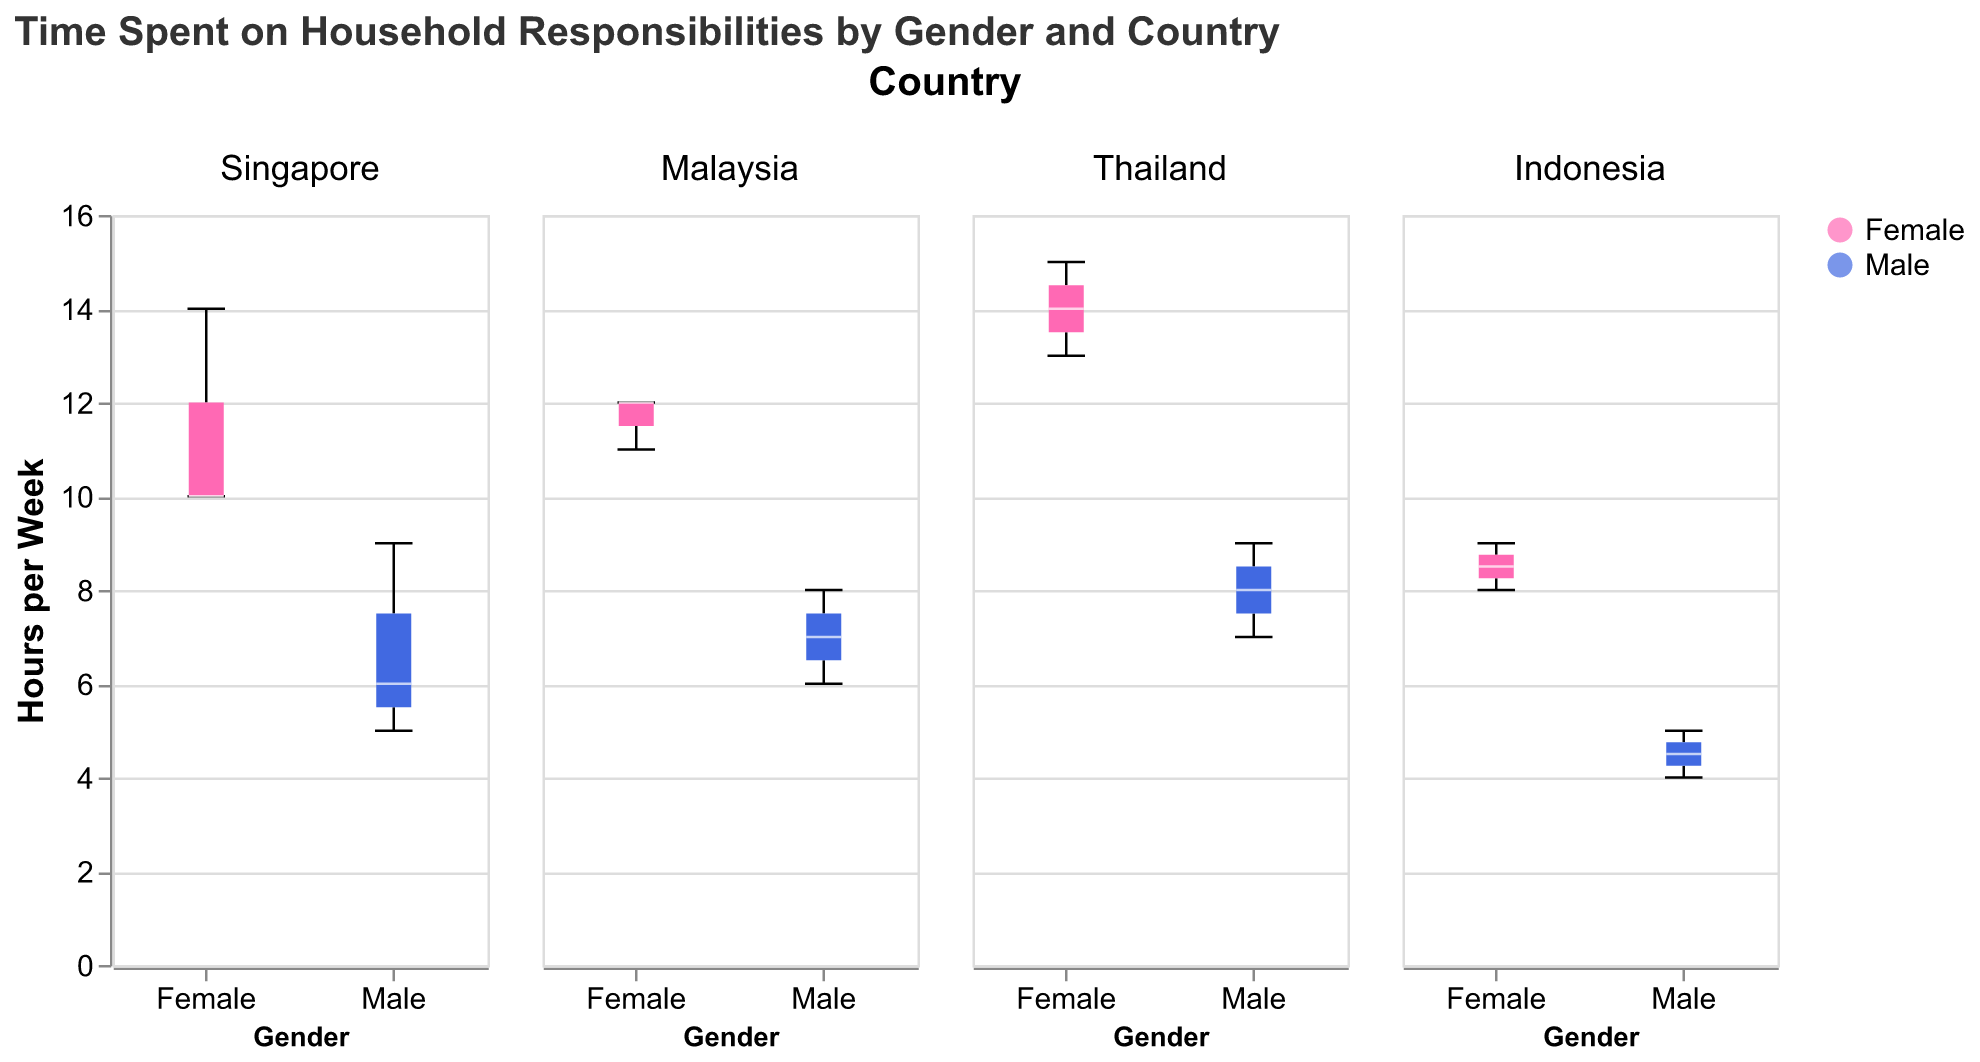What is the title of the plot? The title is located at the top of the figure. It is written in larger font size, making it easily identifiable.
Answer: Time Spent on Household Responsibilities by Gender and Country Which country has the highest median hours spent on household responsibilities for females? To find the country with the highest median, compare the central lines (which represent the medians) of the female box plots across the different countries.
Answer: Thailand What is the median number of hours spent on household responsibilities by males in Singapore? The median is represented by the central line inside the box plot. Locate the box plot for Singapore and the 'Male' category.
Answer: 7 hours How do the median hours spent on household responsibilities compare between males and females in Malaysia? Identify the median lines in the Malaysia subgroup for both genders. Compare their heights to determine which is higher. The female plot has a higher median.
Answer: Females have higher median hours than males What is the interquartile range (IQR) for females in Thailand? The IQR is the difference between the third quartile (top edge of the box) and the first quartile (bottom edge of the box). Measure this visually for the female box plot in Thailand.
Answer: Approximately 3 to 5 hours Which gender has a wider distribution of data points for household responsibilities in Indonesia? The width of the distribution can be observed by the length of the box plot and the whiskers. Compare these lengths between males and females in Indonesia.
Answer: Females Which gender has a more consistent (less varied) range of household responsibility hours in Singapore? A more consistent range is indicated by a shorter box plot. Compare the lengths of the box plots for both genders in Singapore.
Answer: Males In which country is the difference in median household responsibilities between genders the smallest? Compare the median lines for males and females across all countries and find the country where these lines are closest.
Answer: Indonesia What's the maximum number of hours spent on household responsibilities by females in Malaysia? The maximum value is indicated by the top whisker of the female box plot in Malaysia.
Answer: 12 hours 